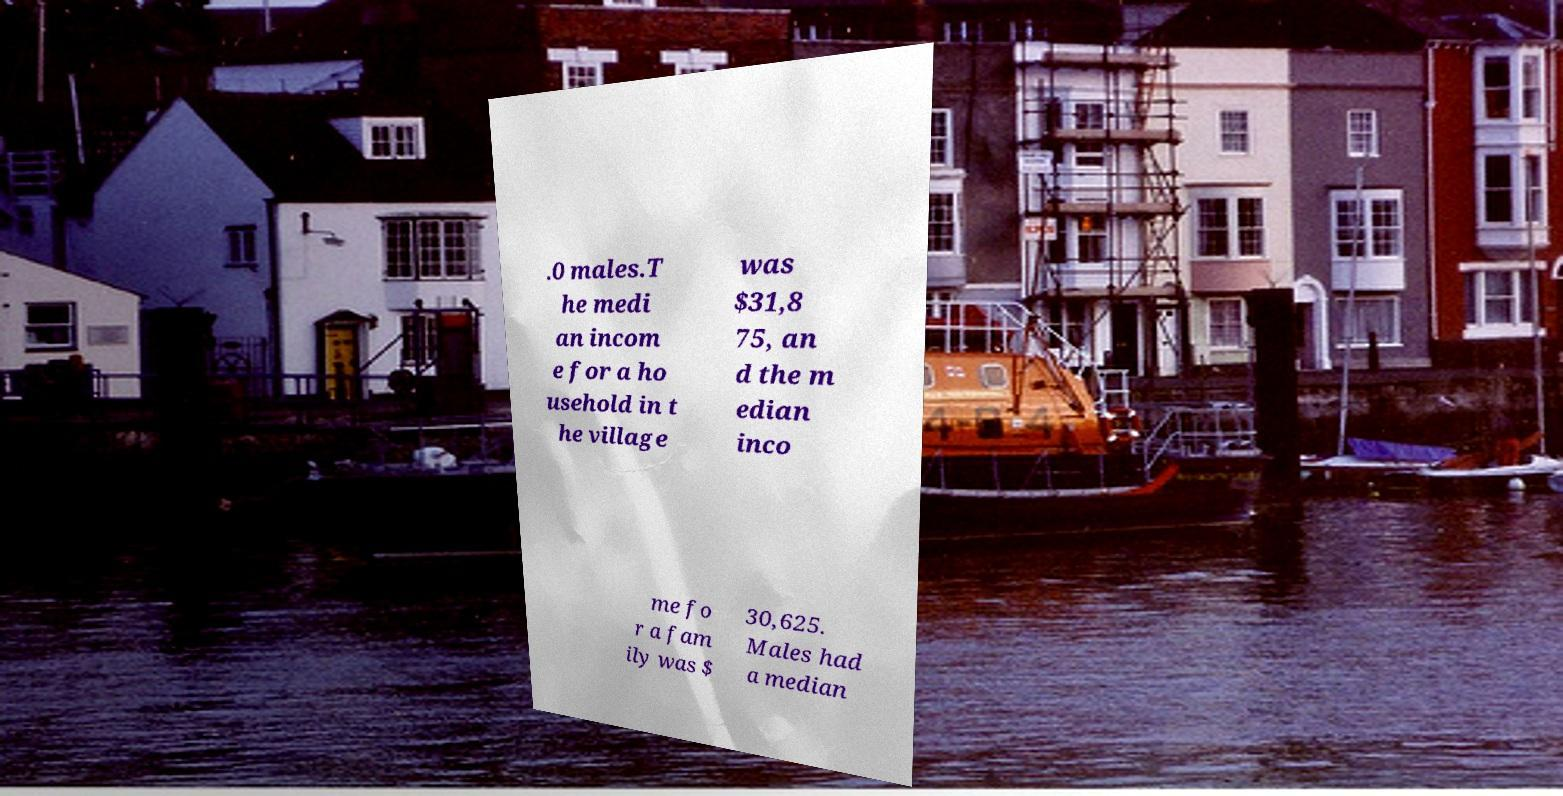Can you accurately transcribe the text from the provided image for me? .0 males.T he medi an incom e for a ho usehold in t he village was $31,8 75, an d the m edian inco me fo r a fam ily was $ 30,625. Males had a median 